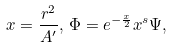Convert formula to latex. <formula><loc_0><loc_0><loc_500><loc_500>x = \frac { r ^ { 2 } } { A ^ { \prime } } , \, \Phi = e ^ { - \frac { x } { 2 } } x ^ { s } \Psi ,</formula> 